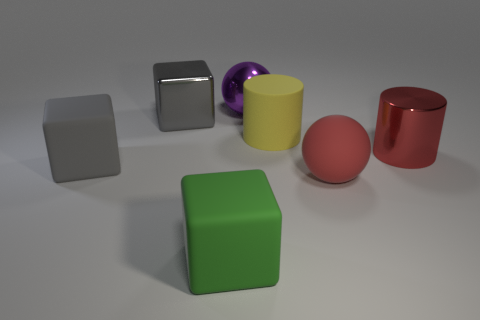What is the color of the metal block that is the same size as the yellow thing? The metal block that matches the yellow object in size has a sleek gray finish, reflecting the surrounding light with a hint of shine characteristic of metallic surfaces. 